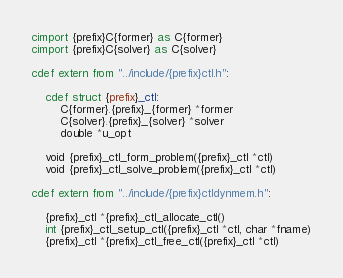Convert code to text. <code><loc_0><loc_0><loc_500><loc_500><_Cython_>cimport {prefix}C{former} as C{former}
cimport {prefix}C{solver} as C{solver}

cdef extern from "../include/{prefix}ctl.h":

    cdef struct {prefix}_ctl:
        C{former}.{prefix}_{former} *former
        C{solver}.{prefix}_{solver} *solver
        double *u_opt

    void {prefix}_ctl_form_problem({prefix}_ctl *ctl)
    void {prefix}_ctl_solve_problem({prefix}_ctl *ctl)

cdef extern from "../include/{prefix}ctldynmem.h":

    {prefix}_ctl *{prefix}_ctl_allocate_ctl()
    int {prefix}_ctl_setup_ctl({prefix}_ctl *ctl, char *fname)
    {prefix}_ctl *{prefix}_ctl_free_ctl({prefix}_ctl *ctl)
</code> 